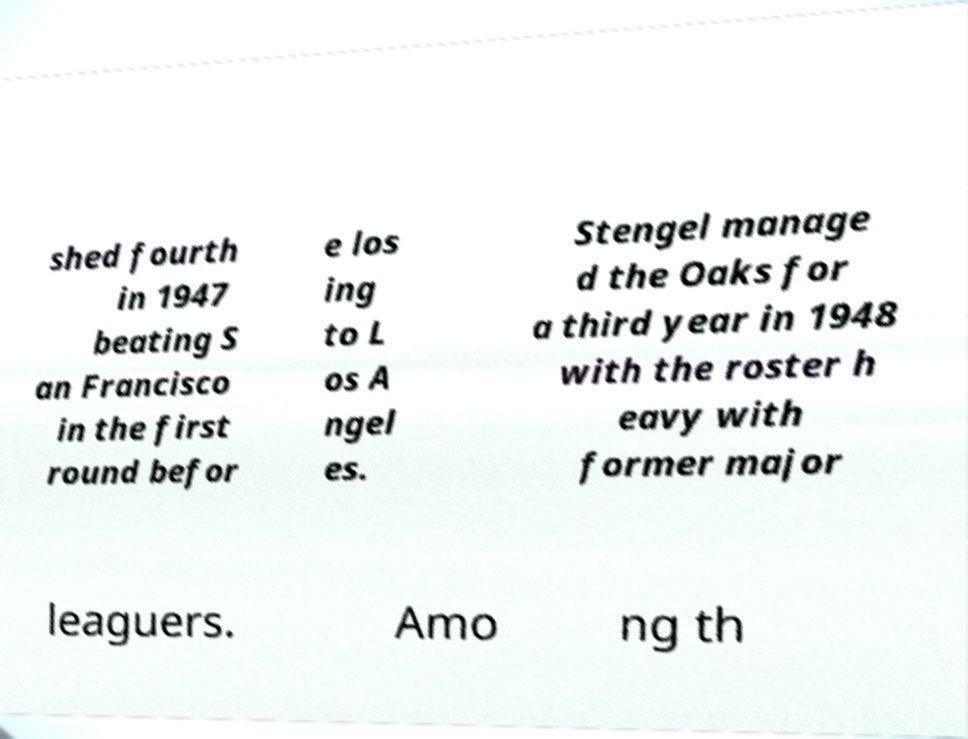There's text embedded in this image that I need extracted. Can you transcribe it verbatim? shed fourth in 1947 beating S an Francisco in the first round befor e los ing to L os A ngel es. Stengel manage d the Oaks for a third year in 1948 with the roster h eavy with former major leaguers. Amo ng th 